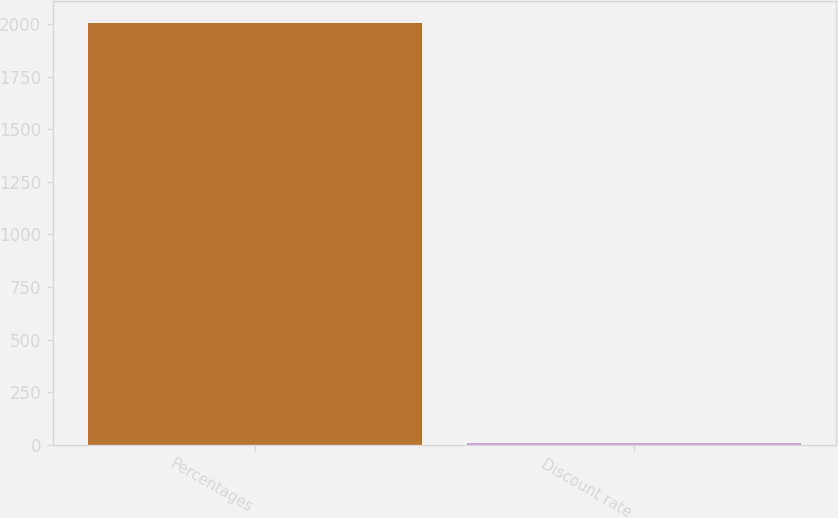<chart> <loc_0><loc_0><loc_500><loc_500><bar_chart><fcel>Percentages<fcel>Discount rate<nl><fcel>2008<fcel>6.25<nl></chart> 